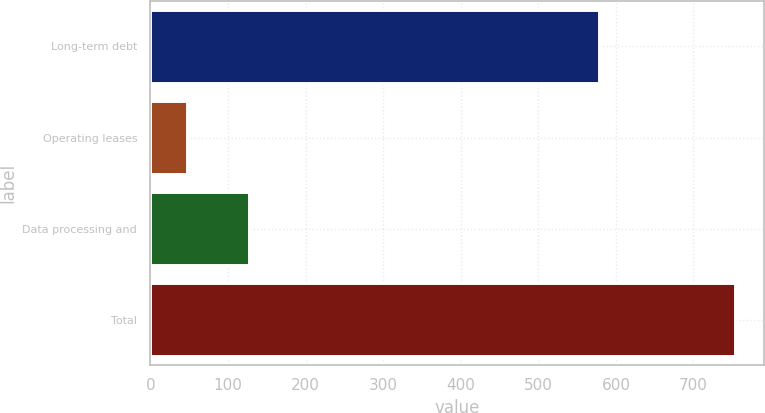<chart> <loc_0><loc_0><loc_500><loc_500><bar_chart><fcel>Long-term debt<fcel>Operating leases<fcel>Data processing and<fcel>Total<nl><fcel>578.7<fcel>47.6<fcel>126.7<fcel>753<nl></chart> 